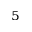Convert formula to latex. <formula><loc_0><loc_0><loc_500><loc_500>^ { 5 }</formula> 